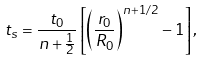<formula> <loc_0><loc_0><loc_500><loc_500>t _ { s } = \frac { t _ { 0 } } { n + \frac { 1 } { 2 } } \left [ \left ( \frac { r _ { 0 } } { R _ { 0 } } \right ) ^ { n + 1 / 2 } - 1 \right ] ,</formula> 